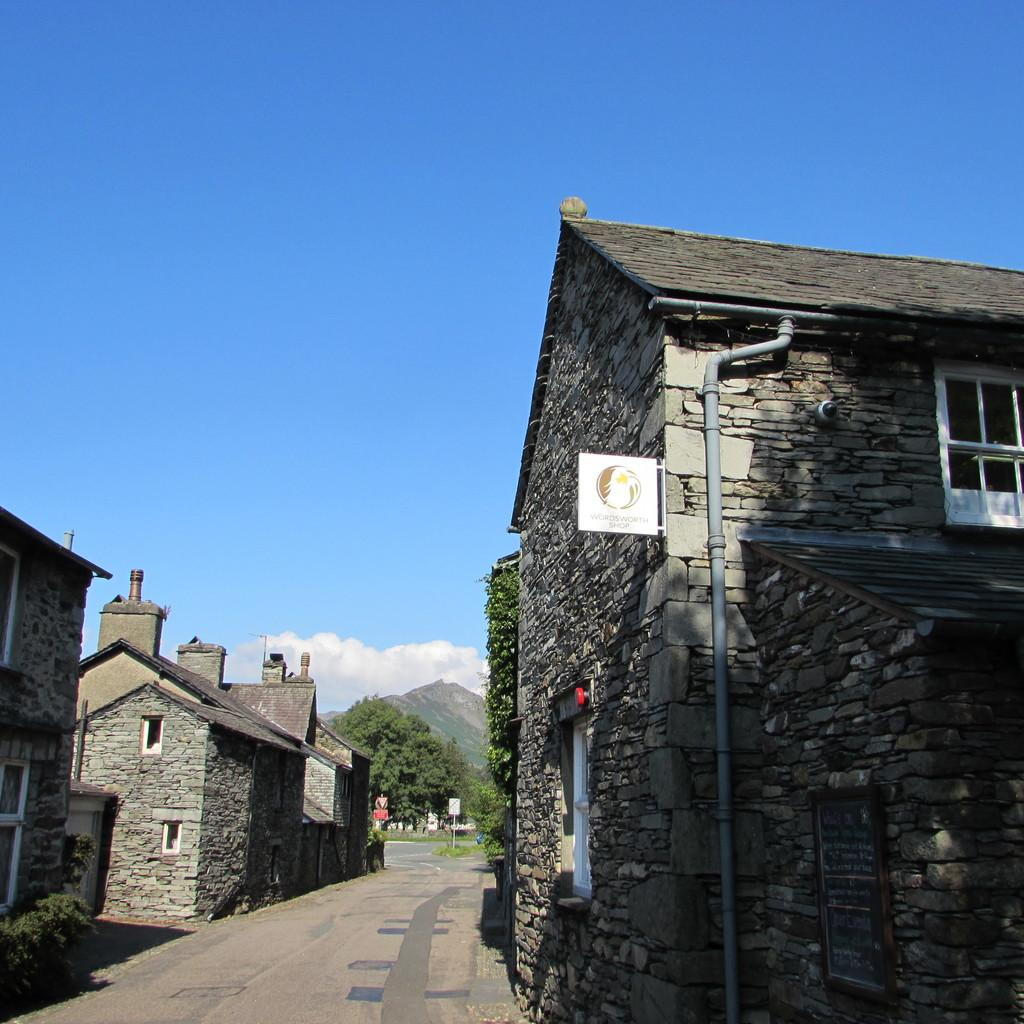What type of structures can be seen in the image? There are houses in the image. What other natural elements are present in the image? There are trees in the image. Are there any man-made objects visible in the image? Yes, there are pipes in the image. What can be seen in the background of the image? There is a hill and clouds visible in the background of the image. What type of music is the band playing in the background of the image? There is no band present in the image, so it is not possible to determine what type of music they might be playing. 